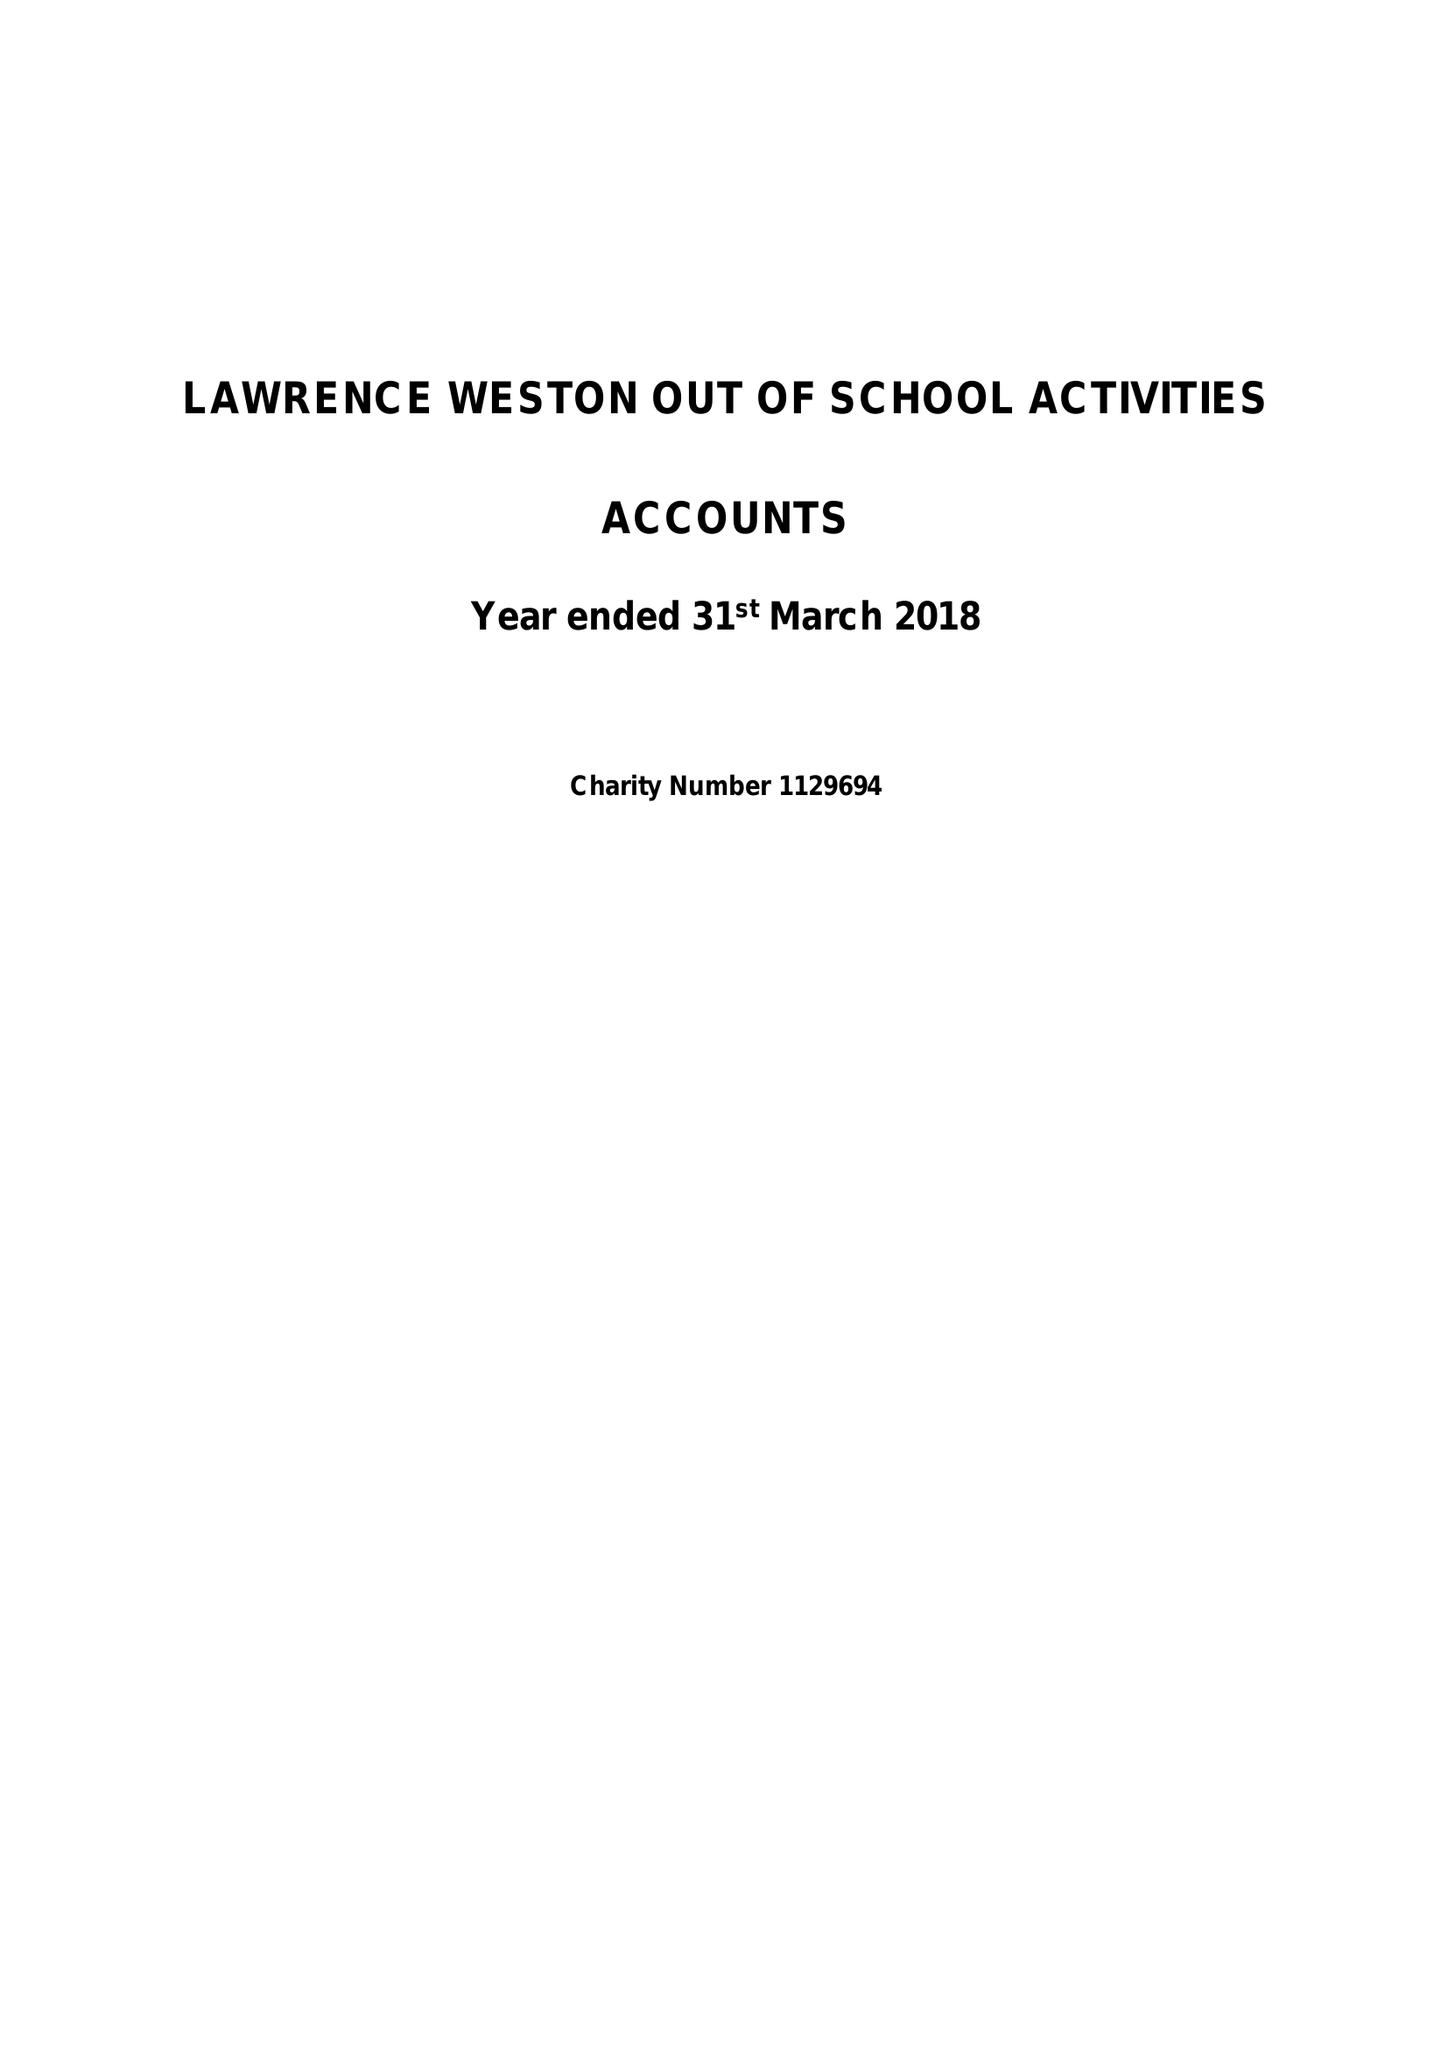What is the value for the charity_name?
Answer the question using a single word or phrase. Lawrence Weston Out Of School Activities 